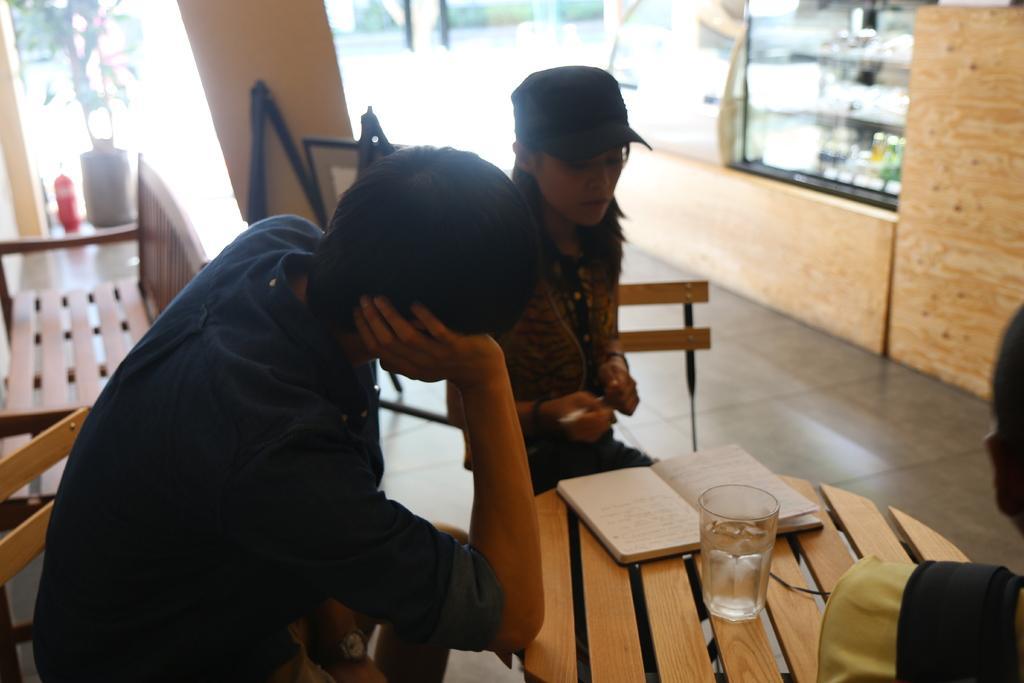In one or two sentences, can you explain what this image depicts? In this picture we can see two people sitting on the chairs in front of the table on which there is a glass and a book and behind them there is a chair. 